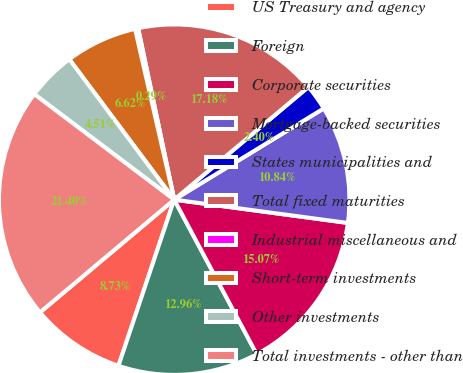Convert chart. <chart><loc_0><loc_0><loc_500><loc_500><pie_chart><fcel>US Treasury and agency<fcel>Foreign<fcel>Corporate securities<fcel>Mortgage-backed securities<fcel>States municipalities and<fcel>Total fixed maturities<fcel>Industrial miscellaneous and<fcel>Short-term investments<fcel>Other investments<fcel>Total investments - other than<nl><fcel>8.73%<fcel>12.96%<fcel>15.07%<fcel>10.84%<fcel>2.4%<fcel>17.18%<fcel>0.29%<fcel>6.62%<fcel>4.51%<fcel>21.4%<nl></chart> 